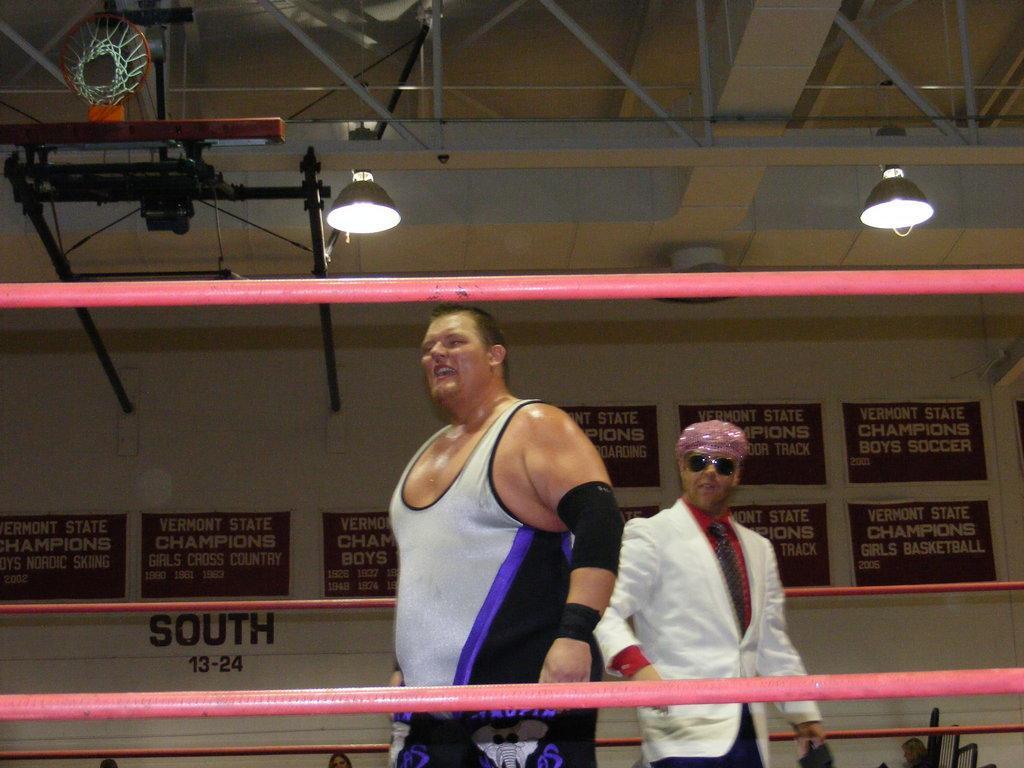In one or two sentences, can you explain what this image depicts? This picture shows the inner view of a building, some objects attached to the ceiling, some iron rods attached to the ceiling, two black poles attached to the wall, two lights, three persons heads, some objects on the ground, some banners with text attached to the wall, some text on the wall, some are threads, two people with smiling faces walking and one man with black sunglasses holding one black object. 